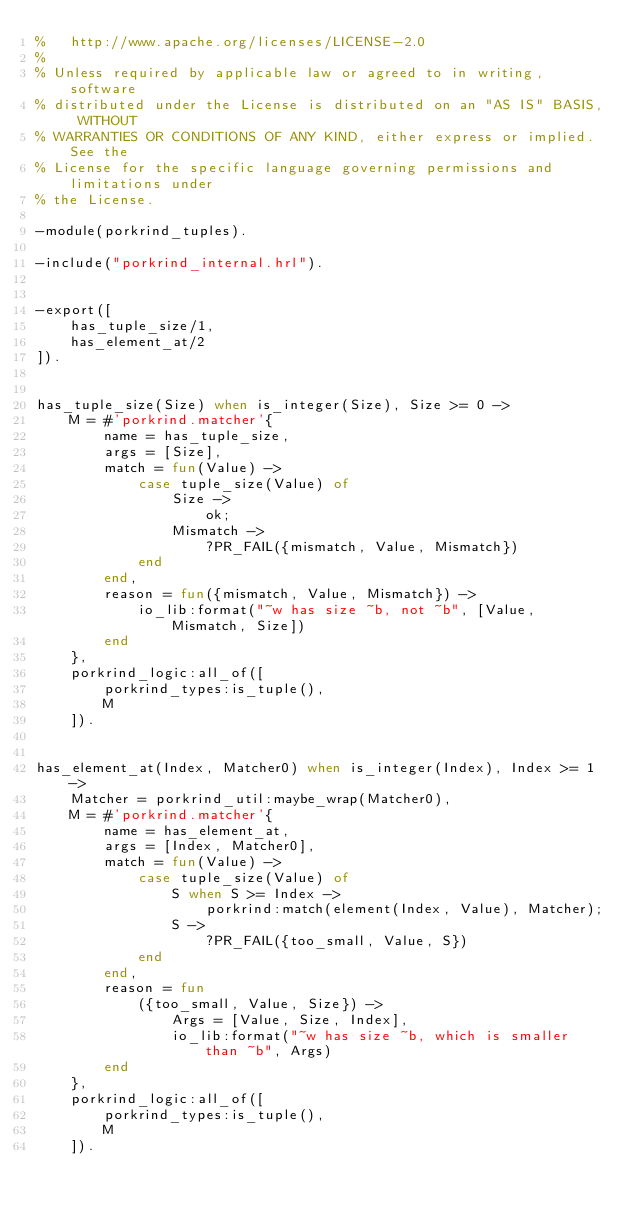<code> <loc_0><loc_0><loc_500><loc_500><_Erlang_>%   http://www.apache.org/licenses/LICENSE-2.0
%
% Unless required by applicable law or agreed to in writing, software
% distributed under the License is distributed on an "AS IS" BASIS, WITHOUT
% WARRANTIES OR CONDITIONS OF ANY KIND, either express or implied. See the
% License for the specific language governing permissions and limitations under
% the License.

-module(porkrind_tuples).

-include("porkrind_internal.hrl").


-export([
    has_tuple_size/1,
    has_element_at/2
]).


has_tuple_size(Size) when is_integer(Size), Size >= 0 ->
    M = #'porkrind.matcher'{
        name = has_tuple_size,
        args = [Size],
        match = fun(Value) ->
            case tuple_size(Value) of
                Size ->
                    ok;
                Mismatch ->
                    ?PR_FAIL({mismatch, Value, Mismatch})
            end
        end,
        reason = fun({mismatch, Value, Mismatch}) ->
            io_lib:format("~w has size ~b, not ~b", [Value, Mismatch, Size])
        end
    },
    porkrind_logic:all_of([
        porkrind_types:is_tuple(),
        M
    ]).


has_element_at(Index, Matcher0) when is_integer(Index), Index >= 1 ->
    Matcher = porkrind_util:maybe_wrap(Matcher0),
    M = #'porkrind.matcher'{
        name = has_element_at,
        args = [Index, Matcher0],
        match = fun(Value) ->
            case tuple_size(Value) of
                S when S >= Index ->
                    porkrind:match(element(Index, Value), Matcher);
                S ->
                    ?PR_FAIL({too_small, Value, S})
            end
        end,
        reason = fun
            ({too_small, Value, Size}) ->
                Args = [Value, Size, Index],
                io_lib:format("~w has size ~b, which is smaller than ~b", Args)
        end
    },
    porkrind_logic:all_of([
        porkrind_types:is_tuple(),
        M
    ]).
</code> 